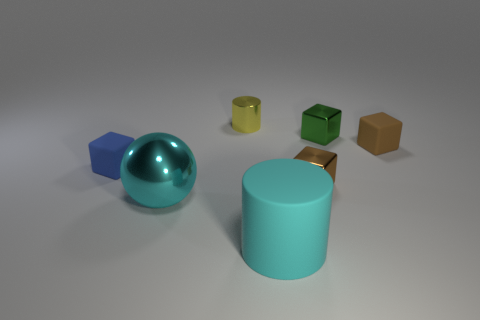What colors are the blocks in the image? The blocks in the image are blue, green, and tan. 